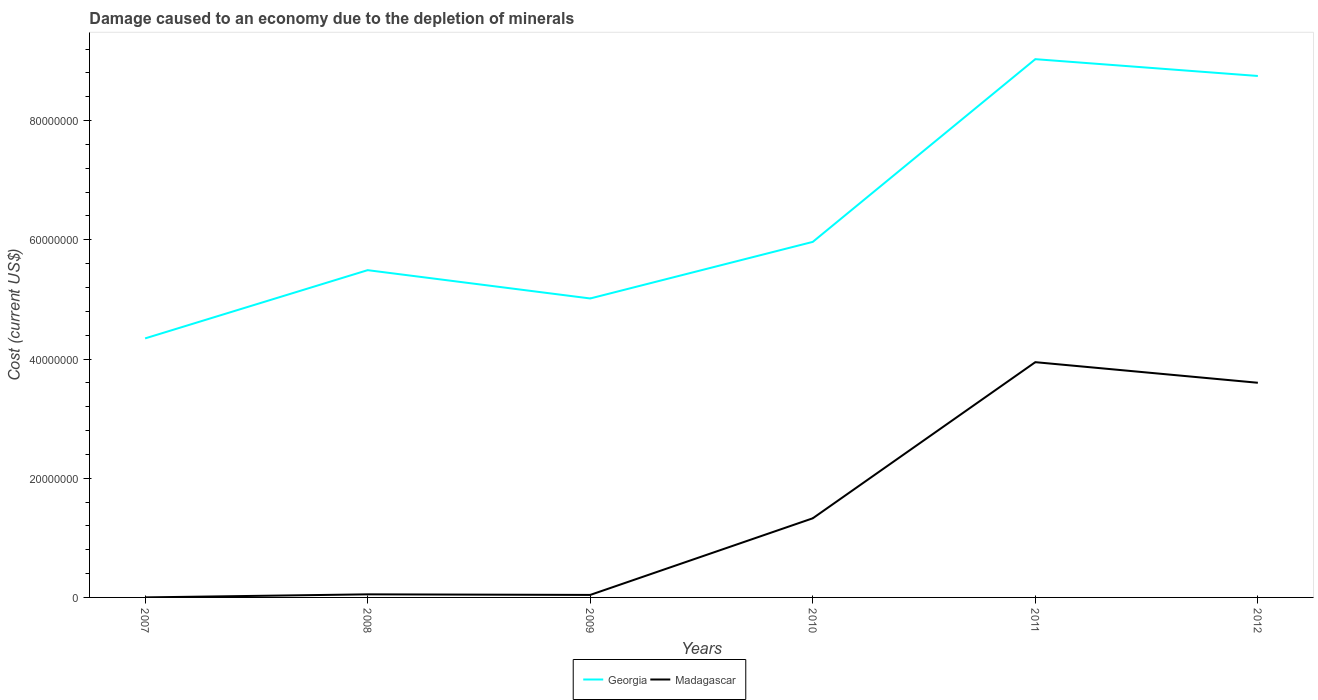Across all years, what is the maximum cost of damage caused due to the depletion of minerals in Georgia?
Your answer should be very brief. 4.35e+07. What is the total cost of damage caused due to the depletion of minerals in Georgia in the graph?
Give a very brief answer. 2.82e+06. What is the difference between the highest and the second highest cost of damage caused due to the depletion of minerals in Georgia?
Provide a short and direct response. 4.69e+07. Is the cost of damage caused due to the depletion of minerals in Georgia strictly greater than the cost of damage caused due to the depletion of minerals in Madagascar over the years?
Provide a short and direct response. No. What is the difference between two consecutive major ticks on the Y-axis?
Keep it short and to the point. 2.00e+07. Does the graph contain any zero values?
Give a very brief answer. No. Does the graph contain grids?
Your response must be concise. No. How many legend labels are there?
Offer a terse response. 2. How are the legend labels stacked?
Give a very brief answer. Horizontal. What is the title of the graph?
Your answer should be compact. Damage caused to an economy due to the depletion of minerals. What is the label or title of the X-axis?
Keep it short and to the point. Years. What is the label or title of the Y-axis?
Provide a short and direct response. Cost (current US$). What is the Cost (current US$) of Georgia in 2007?
Keep it short and to the point. 4.35e+07. What is the Cost (current US$) of Madagascar in 2007?
Offer a very short reply. 4786.46. What is the Cost (current US$) in Georgia in 2008?
Offer a very short reply. 5.49e+07. What is the Cost (current US$) in Madagascar in 2008?
Offer a very short reply. 5.18e+05. What is the Cost (current US$) in Georgia in 2009?
Ensure brevity in your answer.  5.02e+07. What is the Cost (current US$) in Madagascar in 2009?
Your answer should be very brief. 4.19e+05. What is the Cost (current US$) of Georgia in 2010?
Your answer should be very brief. 5.97e+07. What is the Cost (current US$) in Madagascar in 2010?
Your answer should be compact. 1.33e+07. What is the Cost (current US$) of Georgia in 2011?
Keep it short and to the point. 9.03e+07. What is the Cost (current US$) in Madagascar in 2011?
Make the answer very short. 3.95e+07. What is the Cost (current US$) of Georgia in 2012?
Your answer should be compact. 8.75e+07. What is the Cost (current US$) of Madagascar in 2012?
Give a very brief answer. 3.60e+07. Across all years, what is the maximum Cost (current US$) of Georgia?
Your answer should be compact. 9.03e+07. Across all years, what is the maximum Cost (current US$) of Madagascar?
Give a very brief answer. 3.95e+07. Across all years, what is the minimum Cost (current US$) in Georgia?
Your answer should be compact. 4.35e+07. Across all years, what is the minimum Cost (current US$) in Madagascar?
Ensure brevity in your answer.  4786.46. What is the total Cost (current US$) in Georgia in the graph?
Ensure brevity in your answer.  3.86e+08. What is the total Cost (current US$) of Madagascar in the graph?
Provide a short and direct response. 8.97e+07. What is the difference between the Cost (current US$) of Georgia in 2007 and that in 2008?
Ensure brevity in your answer.  -1.15e+07. What is the difference between the Cost (current US$) of Madagascar in 2007 and that in 2008?
Provide a succinct answer. -5.14e+05. What is the difference between the Cost (current US$) in Georgia in 2007 and that in 2009?
Provide a short and direct response. -6.70e+06. What is the difference between the Cost (current US$) of Madagascar in 2007 and that in 2009?
Your response must be concise. -4.14e+05. What is the difference between the Cost (current US$) of Georgia in 2007 and that in 2010?
Provide a succinct answer. -1.62e+07. What is the difference between the Cost (current US$) in Madagascar in 2007 and that in 2010?
Keep it short and to the point. -1.33e+07. What is the difference between the Cost (current US$) in Georgia in 2007 and that in 2011?
Give a very brief answer. -4.69e+07. What is the difference between the Cost (current US$) in Madagascar in 2007 and that in 2011?
Your answer should be very brief. -3.95e+07. What is the difference between the Cost (current US$) of Georgia in 2007 and that in 2012?
Keep it short and to the point. -4.40e+07. What is the difference between the Cost (current US$) in Madagascar in 2007 and that in 2012?
Make the answer very short. -3.60e+07. What is the difference between the Cost (current US$) in Georgia in 2008 and that in 2009?
Give a very brief answer. 4.75e+06. What is the difference between the Cost (current US$) in Madagascar in 2008 and that in 2009?
Offer a very short reply. 9.90e+04. What is the difference between the Cost (current US$) of Georgia in 2008 and that in 2010?
Your answer should be compact. -4.74e+06. What is the difference between the Cost (current US$) of Madagascar in 2008 and that in 2010?
Make the answer very short. -1.28e+07. What is the difference between the Cost (current US$) in Georgia in 2008 and that in 2011?
Your response must be concise. -3.54e+07. What is the difference between the Cost (current US$) of Madagascar in 2008 and that in 2011?
Offer a terse response. -3.90e+07. What is the difference between the Cost (current US$) in Georgia in 2008 and that in 2012?
Offer a very short reply. -3.26e+07. What is the difference between the Cost (current US$) of Madagascar in 2008 and that in 2012?
Ensure brevity in your answer.  -3.55e+07. What is the difference between the Cost (current US$) in Georgia in 2009 and that in 2010?
Your answer should be compact. -9.49e+06. What is the difference between the Cost (current US$) in Madagascar in 2009 and that in 2010?
Provide a succinct answer. -1.29e+07. What is the difference between the Cost (current US$) in Georgia in 2009 and that in 2011?
Offer a terse response. -4.02e+07. What is the difference between the Cost (current US$) of Madagascar in 2009 and that in 2011?
Give a very brief answer. -3.91e+07. What is the difference between the Cost (current US$) in Georgia in 2009 and that in 2012?
Make the answer very short. -3.73e+07. What is the difference between the Cost (current US$) in Madagascar in 2009 and that in 2012?
Give a very brief answer. -3.56e+07. What is the difference between the Cost (current US$) in Georgia in 2010 and that in 2011?
Ensure brevity in your answer.  -3.07e+07. What is the difference between the Cost (current US$) of Madagascar in 2010 and that in 2011?
Make the answer very short. -2.62e+07. What is the difference between the Cost (current US$) in Georgia in 2010 and that in 2012?
Provide a short and direct response. -2.78e+07. What is the difference between the Cost (current US$) of Madagascar in 2010 and that in 2012?
Offer a very short reply. -2.27e+07. What is the difference between the Cost (current US$) of Georgia in 2011 and that in 2012?
Offer a terse response. 2.82e+06. What is the difference between the Cost (current US$) in Madagascar in 2011 and that in 2012?
Provide a succinct answer. 3.46e+06. What is the difference between the Cost (current US$) in Georgia in 2007 and the Cost (current US$) in Madagascar in 2008?
Provide a succinct answer. 4.29e+07. What is the difference between the Cost (current US$) in Georgia in 2007 and the Cost (current US$) in Madagascar in 2009?
Keep it short and to the point. 4.30e+07. What is the difference between the Cost (current US$) of Georgia in 2007 and the Cost (current US$) of Madagascar in 2010?
Your answer should be compact. 3.02e+07. What is the difference between the Cost (current US$) in Georgia in 2007 and the Cost (current US$) in Madagascar in 2011?
Ensure brevity in your answer.  3.99e+06. What is the difference between the Cost (current US$) of Georgia in 2007 and the Cost (current US$) of Madagascar in 2012?
Your answer should be very brief. 7.44e+06. What is the difference between the Cost (current US$) in Georgia in 2008 and the Cost (current US$) in Madagascar in 2009?
Make the answer very short. 5.45e+07. What is the difference between the Cost (current US$) of Georgia in 2008 and the Cost (current US$) of Madagascar in 2010?
Provide a succinct answer. 4.16e+07. What is the difference between the Cost (current US$) in Georgia in 2008 and the Cost (current US$) in Madagascar in 2011?
Keep it short and to the point. 1.54e+07. What is the difference between the Cost (current US$) in Georgia in 2008 and the Cost (current US$) in Madagascar in 2012?
Offer a very short reply. 1.89e+07. What is the difference between the Cost (current US$) of Georgia in 2009 and the Cost (current US$) of Madagascar in 2010?
Provide a short and direct response. 3.69e+07. What is the difference between the Cost (current US$) of Georgia in 2009 and the Cost (current US$) of Madagascar in 2011?
Provide a succinct answer. 1.07e+07. What is the difference between the Cost (current US$) of Georgia in 2009 and the Cost (current US$) of Madagascar in 2012?
Keep it short and to the point. 1.41e+07. What is the difference between the Cost (current US$) in Georgia in 2010 and the Cost (current US$) in Madagascar in 2011?
Offer a very short reply. 2.02e+07. What is the difference between the Cost (current US$) in Georgia in 2010 and the Cost (current US$) in Madagascar in 2012?
Offer a terse response. 2.36e+07. What is the difference between the Cost (current US$) of Georgia in 2011 and the Cost (current US$) of Madagascar in 2012?
Offer a terse response. 5.43e+07. What is the average Cost (current US$) of Georgia per year?
Provide a succinct answer. 6.43e+07. What is the average Cost (current US$) of Madagascar per year?
Your answer should be very brief. 1.50e+07. In the year 2007, what is the difference between the Cost (current US$) of Georgia and Cost (current US$) of Madagascar?
Your response must be concise. 4.35e+07. In the year 2008, what is the difference between the Cost (current US$) of Georgia and Cost (current US$) of Madagascar?
Offer a very short reply. 5.44e+07. In the year 2009, what is the difference between the Cost (current US$) in Georgia and Cost (current US$) in Madagascar?
Keep it short and to the point. 4.97e+07. In the year 2010, what is the difference between the Cost (current US$) in Georgia and Cost (current US$) in Madagascar?
Keep it short and to the point. 4.64e+07. In the year 2011, what is the difference between the Cost (current US$) of Georgia and Cost (current US$) of Madagascar?
Your answer should be very brief. 5.08e+07. In the year 2012, what is the difference between the Cost (current US$) of Georgia and Cost (current US$) of Madagascar?
Provide a succinct answer. 5.15e+07. What is the ratio of the Cost (current US$) of Georgia in 2007 to that in 2008?
Your answer should be compact. 0.79. What is the ratio of the Cost (current US$) of Madagascar in 2007 to that in 2008?
Keep it short and to the point. 0.01. What is the ratio of the Cost (current US$) of Georgia in 2007 to that in 2009?
Your response must be concise. 0.87. What is the ratio of the Cost (current US$) in Madagascar in 2007 to that in 2009?
Ensure brevity in your answer.  0.01. What is the ratio of the Cost (current US$) of Georgia in 2007 to that in 2010?
Offer a very short reply. 0.73. What is the ratio of the Cost (current US$) in Madagascar in 2007 to that in 2010?
Provide a succinct answer. 0. What is the ratio of the Cost (current US$) in Georgia in 2007 to that in 2011?
Your response must be concise. 0.48. What is the ratio of the Cost (current US$) of Georgia in 2007 to that in 2012?
Your response must be concise. 0.5. What is the ratio of the Cost (current US$) of Madagascar in 2007 to that in 2012?
Provide a succinct answer. 0. What is the ratio of the Cost (current US$) of Georgia in 2008 to that in 2009?
Offer a terse response. 1.09. What is the ratio of the Cost (current US$) of Madagascar in 2008 to that in 2009?
Offer a terse response. 1.24. What is the ratio of the Cost (current US$) of Georgia in 2008 to that in 2010?
Your response must be concise. 0.92. What is the ratio of the Cost (current US$) in Madagascar in 2008 to that in 2010?
Provide a succinct answer. 0.04. What is the ratio of the Cost (current US$) in Georgia in 2008 to that in 2011?
Provide a short and direct response. 0.61. What is the ratio of the Cost (current US$) of Madagascar in 2008 to that in 2011?
Your answer should be very brief. 0.01. What is the ratio of the Cost (current US$) in Georgia in 2008 to that in 2012?
Offer a terse response. 0.63. What is the ratio of the Cost (current US$) in Madagascar in 2008 to that in 2012?
Provide a succinct answer. 0.01. What is the ratio of the Cost (current US$) of Georgia in 2009 to that in 2010?
Make the answer very short. 0.84. What is the ratio of the Cost (current US$) in Madagascar in 2009 to that in 2010?
Your answer should be compact. 0.03. What is the ratio of the Cost (current US$) of Georgia in 2009 to that in 2011?
Provide a succinct answer. 0.56. What is the ratio of the Cost (current US$) in Madagascar in 2009 to that in 2011?
Offer a terse response. 0.01. What is the ratio of the Cost (current US$) of Georgia in 2009 to that in 2012?
Your answer should be very brief. 0.57. What is the ratio of the Cost (current US$) of Madagascar in 2009 to that in 2012?
Give a very brief answer. 0.01. What is the ratio of the Cost (current US$) of Georgia in 2010 to that in 2011?
Ensure brevity in your answer.  0.66. What is the ratio of the Cost (current US$) of Madagascar in 2010 to that in 2011?
Ensure brevity in your answer.  0.34. What is the ratio of the Cost (current US$) of Georgia in 2010 to that in 2012?
Give a very brief answer. 0.68. What is the ratio of the Cost (current US$) in Madagascar in 2010 to that in 2012?
Ensure brevity in your answer.  0.37. What is the ratio of the Cost (current US$) in Georgia in 2011 to that in 2012?
Make the answer very short. 1.03. What is the ratio of the Cost (current US$) in Madagascar in 2011 to that in 2012?
Your response must be concise. 1.1. What is the difference between the highest and the second highest Cost (current US$) in Georgia?
Offer a very short reply. 2.82e+06. What is the difference between the highest and the second highest Cost (current US$) of Madagascar?
Make the answer very short. 3.46e+06. What is the difference between the highest and the lowest Cost (current US$) in Georgia?
Offer a very short reply. 4.69e+07. What is the difference between the highest and the lowest Cost (current US$) in Madagascar?
Offer a terse response. 3.95e+07. 